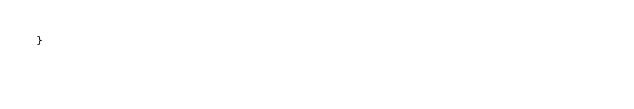Convert code to text. <code><loc_0><loc_0><loc_500><loc_500><_CSS_>}</code> 